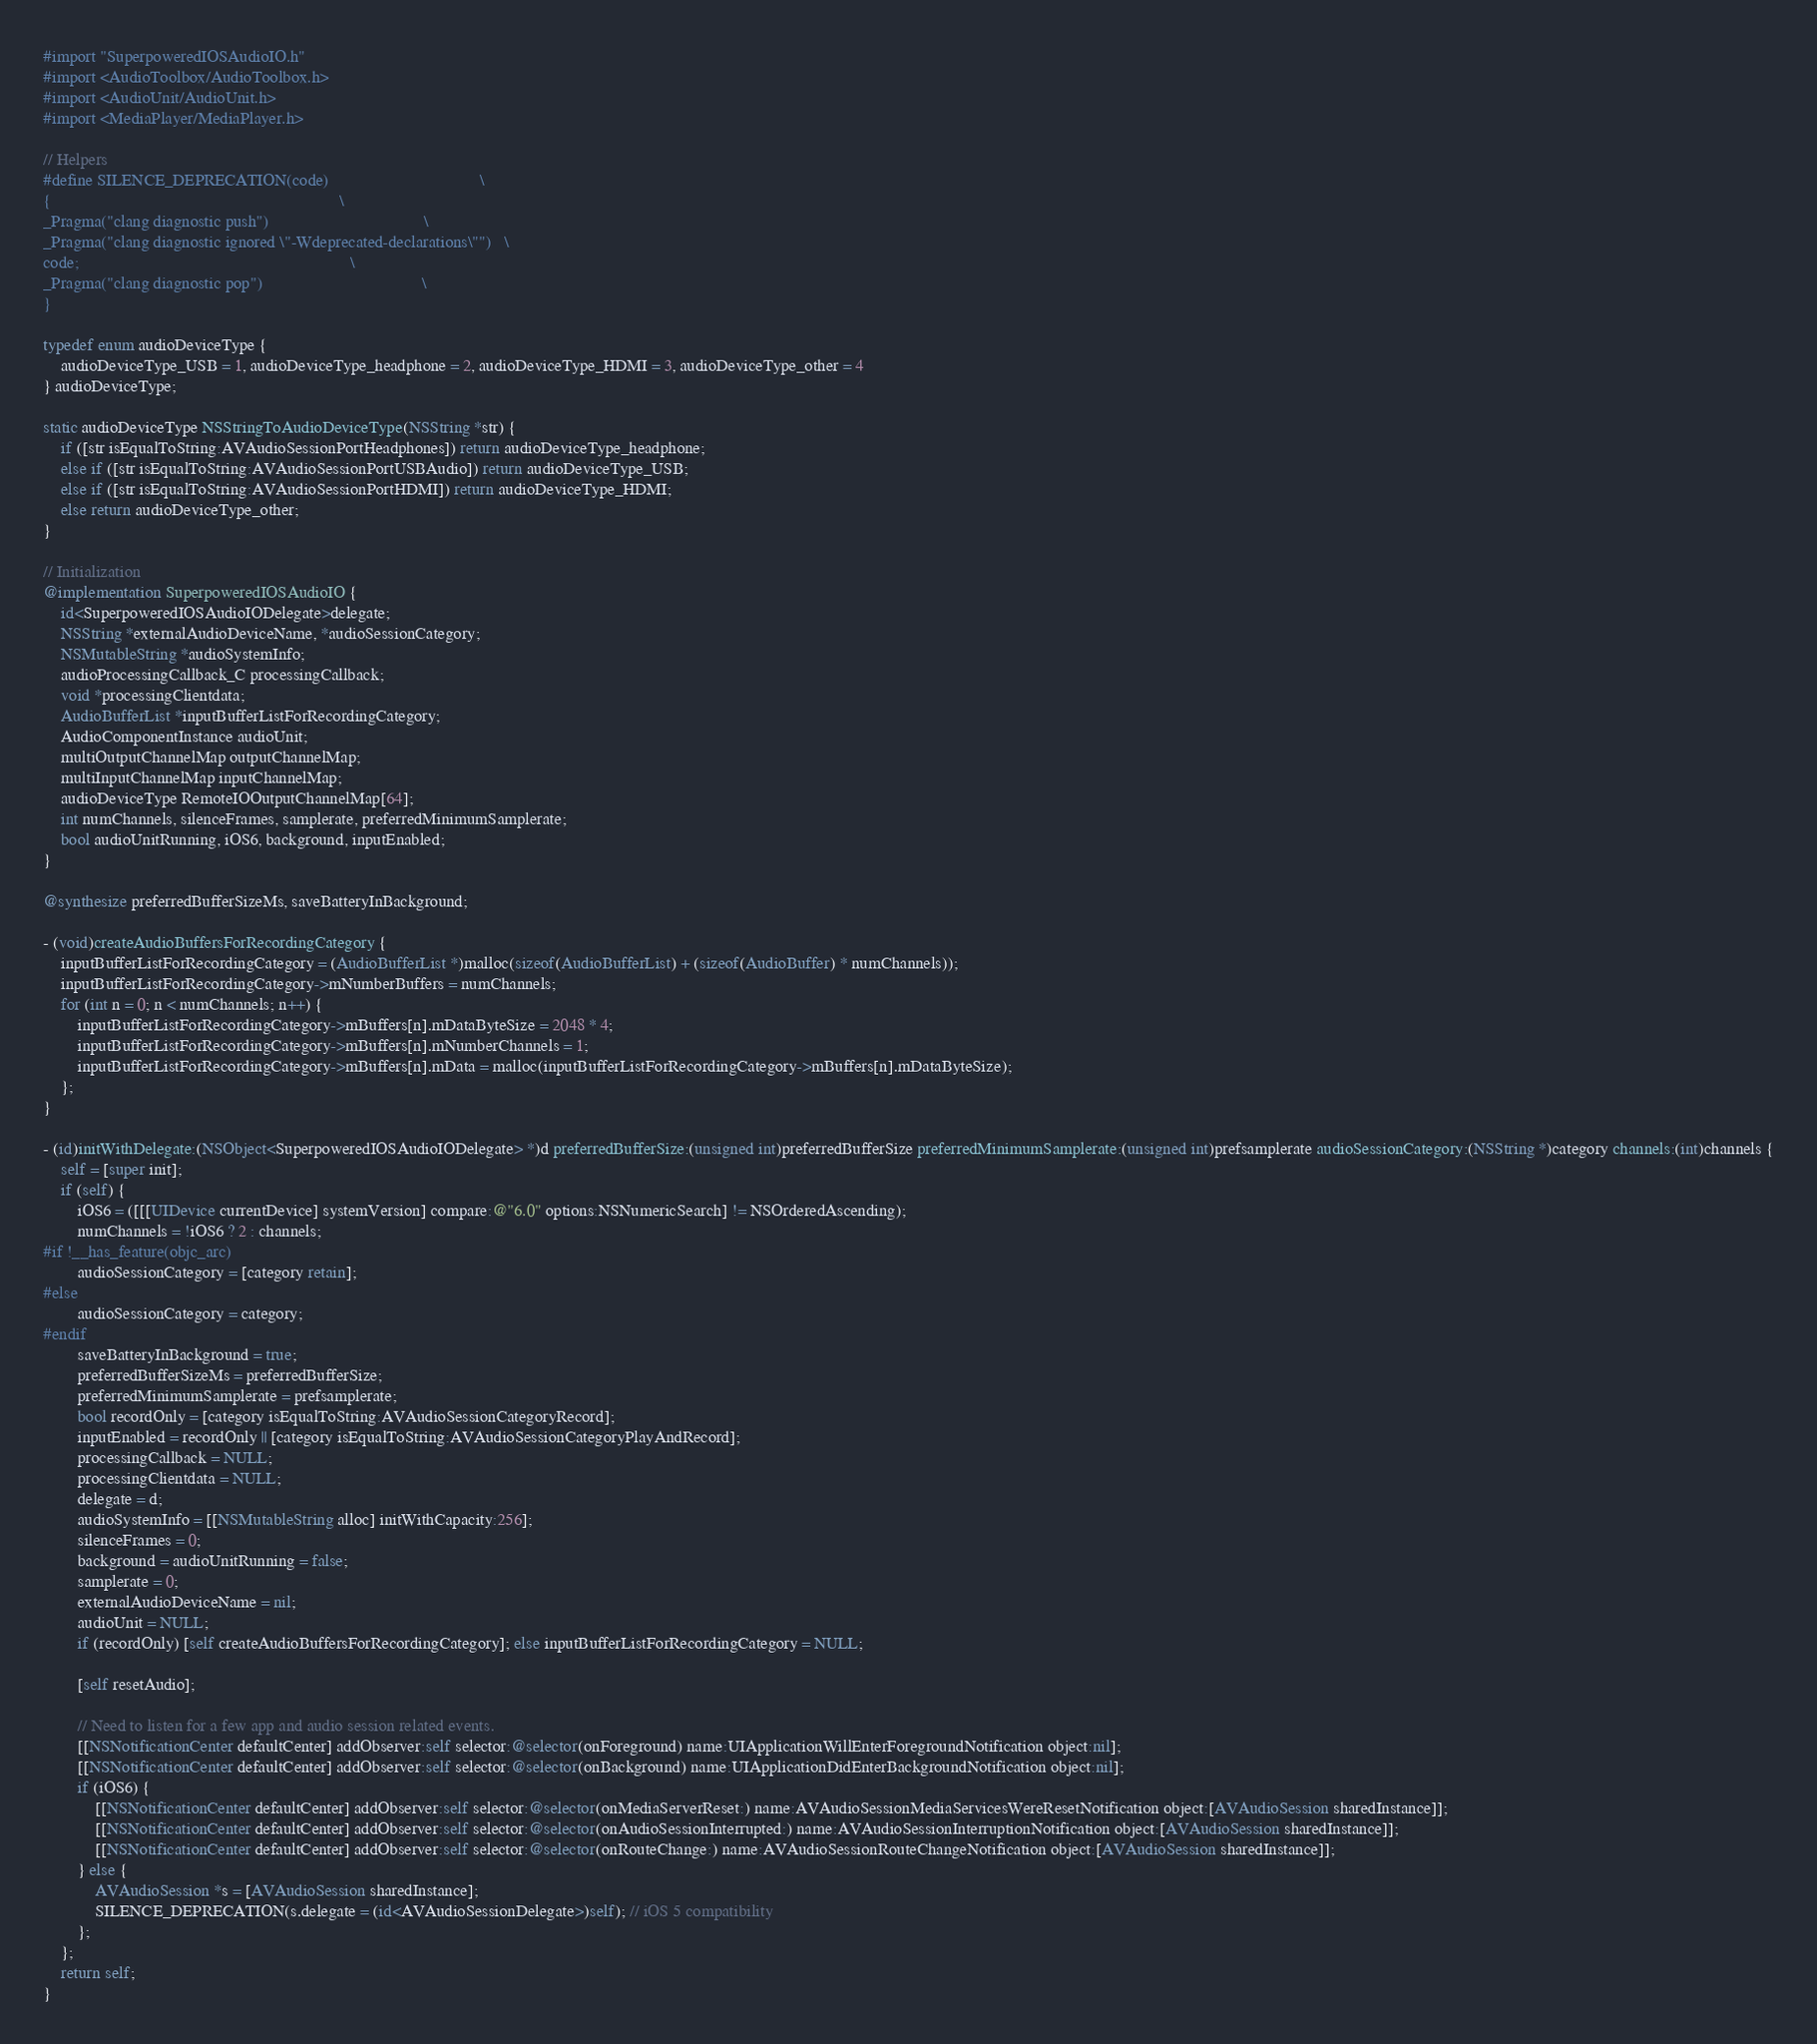<code> <loc_0><loc_0><loc_500><loc_500><_ObjectiveC_>#import "SuperpoweredIOSAudioIO.h"
#import <AudioToolbox/AudioToolbox.h>
#import <AudioUnit/AudioUnit.h>
#import <MediaPlayer/MediaPlayer.h>

// Helpers
#define SILENCE_DEPRECATION(code)                                   \
{                                                                   \
_Pragma("clang diagnostic push")                                    \
_Pragma("clang diagnostic ignored \"-Wdeprecated-declarations\"")   \
code;                                                               \
_Pragma("clang diagnostic pop")                                     \
}

typedef enum audioDeviceType {
    audioDeviceType_USB = 1, audioDeviceType_headphone = 2, audioDeviceType_HDMI = 3, audioDeviceType_other = 4
} audioDeviceType;

static audioDeviceType NSStringToAudioDeviceType(NSString *str) {
    if ([str isEqualToString:AVAudioSessionPortHeadphones]) return audioDeviceType_headphone;
    else if ([str isEqualToString:AVAudioSessionPortUSBAudio]) return audioDeviceType_USB;
    else if ([str isEqualToString:AVAudioSessionPortHDMI]) return audioDeviceType_HDMI;
    else return audioDeviceType_other;
}

// Initialization
@implementation SuperpoweredIOSAudioIO {
    id<SuperpoweredIOSAudioIODelegate>delegate;
    NSString *externalAudioDeviceName, *audioSessionCategory;
    NSMutableString *audioSystemInfo;
    audioProcessingCallback_C processingCallback;
    void *processingClientdata;
    AudioBufferList *inputBufferListForRecordingCategory;
    AudioComponentInstance audioUnit;
    multiOutputChannelMap outputChannelMap;
    multiInputChannelMap inputChannelMap;
    audioDeviceType RemoteIOOutputChannelMap[64];
    int numChannels, silenceFrames, samplerate, preferredMinimumSamplerate;
    bool audioUnitRunning, iOS6, background, inputEnabled;
}

@synthesize preferredBufferSizeMs, saveBatteryInBackground;

- (void)createAudioBuffersForRecordingCategory {
    inputBufferListForRecordingCategory = (AudioBufferList *)malloc(sizeof(AudioBufferList) + (sizeof(AudioBuffer) * numChannels));
    inputBufferListForRecordingCategory->mNumberBuffers = numChannels;
    for (int n = 0; n < numChannels; n++) {
        inputBufferListForRecordingCategory->mBuffers[n].mDataByteSize = 2048 * 4;
        inputBufferListForRecordingCategory->mBuffers[n].mNumberChannels = 1;
        inputBufferListForRecordingCategory->mBuffers[n].mData = malloc(inputBufferListForRecordingCategory->mBuffers[n].mDataByteSize);
    };
}

- (id)initWithDelegate:(NSObject<SuperpoweredIOSAudioIODelegate> *)d preferredBufferSize:(unsigned int)preferredBufferSize preferredMinimumSamplerate:(unsigned int)prefsamplerate audioSessionCategory:(NSString *)category channels:(int)channels {
    self = [super init];
    if (self) {
        iOS6 = ([[[UIDevice currentDevice] systemVersion] compare:@"6.0" options:NSNumericSearch] != NSOrderedAscending);
        numChannels = !iOS6 ? 2 : channels;
#if !__has_feature(objc_arc)
        audioSessionCategory = [category retain];
#else
        audioSessionCategory = category;
#endif
        saveBatteryInBackground = true;
        preferredBufferSizeMs = preferredBufferSize;
        preferredMinimumSamplerate = prefsamplerate;
        bool recordOnly = [category isEqualToString:AVAudioSessionCategoryRecord];
        inputEnabled = recordOnly || [category isEqualToString:AVAudioSessionCategoryPlayAndRecord];
        processingCallback = NULL;
        processingClientdata = NULL;
        delegate = d;
        audioSystemInfo = [[NSMutableString alloc] initWithCapacity:256];
        silenceFrames = 0;
        background = audioUnitRunning = false;
        samplerate = 0;
        externalAudioDeviceName = nil;
        audioUnit = NULL;
        if (recordOnly) [self createAudioBuffersForRecordingCategory]; else inputBufferListForRecordingCategory = NULL;

        [self resetAudio];
        
        // Need to listen for a few app and audio session related events.
        [[NSNotificationCenter defaultCenter] addObserver:self selector:@selector(onForeground) name:UIApplicationWillEnterForegroundNotification object:nil];
        [[NSNotificationCenter defaultCenter] addObserver:self selector:@selector(onBackground) name:UIApplicationDidEnterBackgroundNotification object:nil];
        if (iOS6) {
            [[NSNotificationCenter defaultCenter] addObserver:self selector:@selector(onMediaServerReset:) name:AVAudioSessionMediaServicesWereResetNotification object:[AVAudioSession sharedInstance]];
            [[NSNotificationCenter defaultCenter] addObserver:self selector:@selector(onAudioSessionInterrupted:) name:AVAudioSessionInterruptionNotification object:[AVAudioSession sharedInstance]];
            [[NSNotificationCenter defaultCenter] addObserver:self selector:@selector(onRouteChange:) name:AVAudioSessionRouteChangeNotification object:[AVAudioSession sharedInstance]];
        } else {
            AVAudioSession *s = [AVAudioSession sharedInstance];
            SILENCE_DEPRECATION(s.delegate = (id<AVAudioSessionDelegate>)self); // iOS 5 compatibility
        };
    };
    return self;
}
</code> 